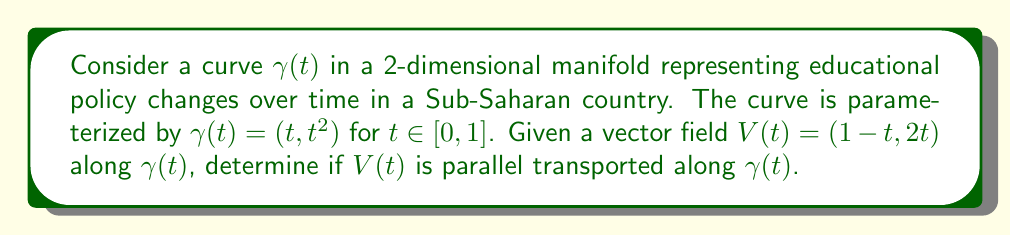Can you answer this question? To determine if $V(t)$ is parallel transported along $\gamma(t)$, we need to check if the covariant derivative of $V(t)$ along $\gamma(t)$ is zero. Let's follow these steps:

1) The tangent vector to $\gamma(t)$ is $\dot{\gamma}(t) = (1, 2t)$.

2) For parallel transport, we need to check if $\nabla_{\dot{\gamma}} V = 0$, where $\nabla$ is the Levi-Civita connection.

3) In coordinates, the condition for parallel transport is:

   $$\frac{dV^i}{dt} + \sum_{j,k} \Gamma^i_{jk} \frac{dx^j}{dt} V^k = 0$$

   where $\Gamma^i_{jk}$ are the Christoffel symbols.

4) For a flat manifold (which we assume here for simplicity), all Christoffel symbols are zero.

5) Therefore, our condition simplifies to:

   $$\frac{dV^i}{dt} = 0$$

6) Let's check this condition for each component of $V(t)$:

   For $V^1(t) = 1-t$:
   $$\frac{dV^1}{dt} = -1 \neq 0$$

   For $V^2(t) = 2t$:
   $$\frac{dV^2}{dt} = 2 \neq 0$$

7) Since both derivatives are non-zero, $V(t)$ is not parallel transported along $\gamma(t)$.

This result suggests that the vector field representing educational policy changes is not consistent (parallel) along the curve of time, indicating varying policy directions or intensities over the studied period.
Answer: $V(t)$ is not parallel transported along $\gamma(t)$. 